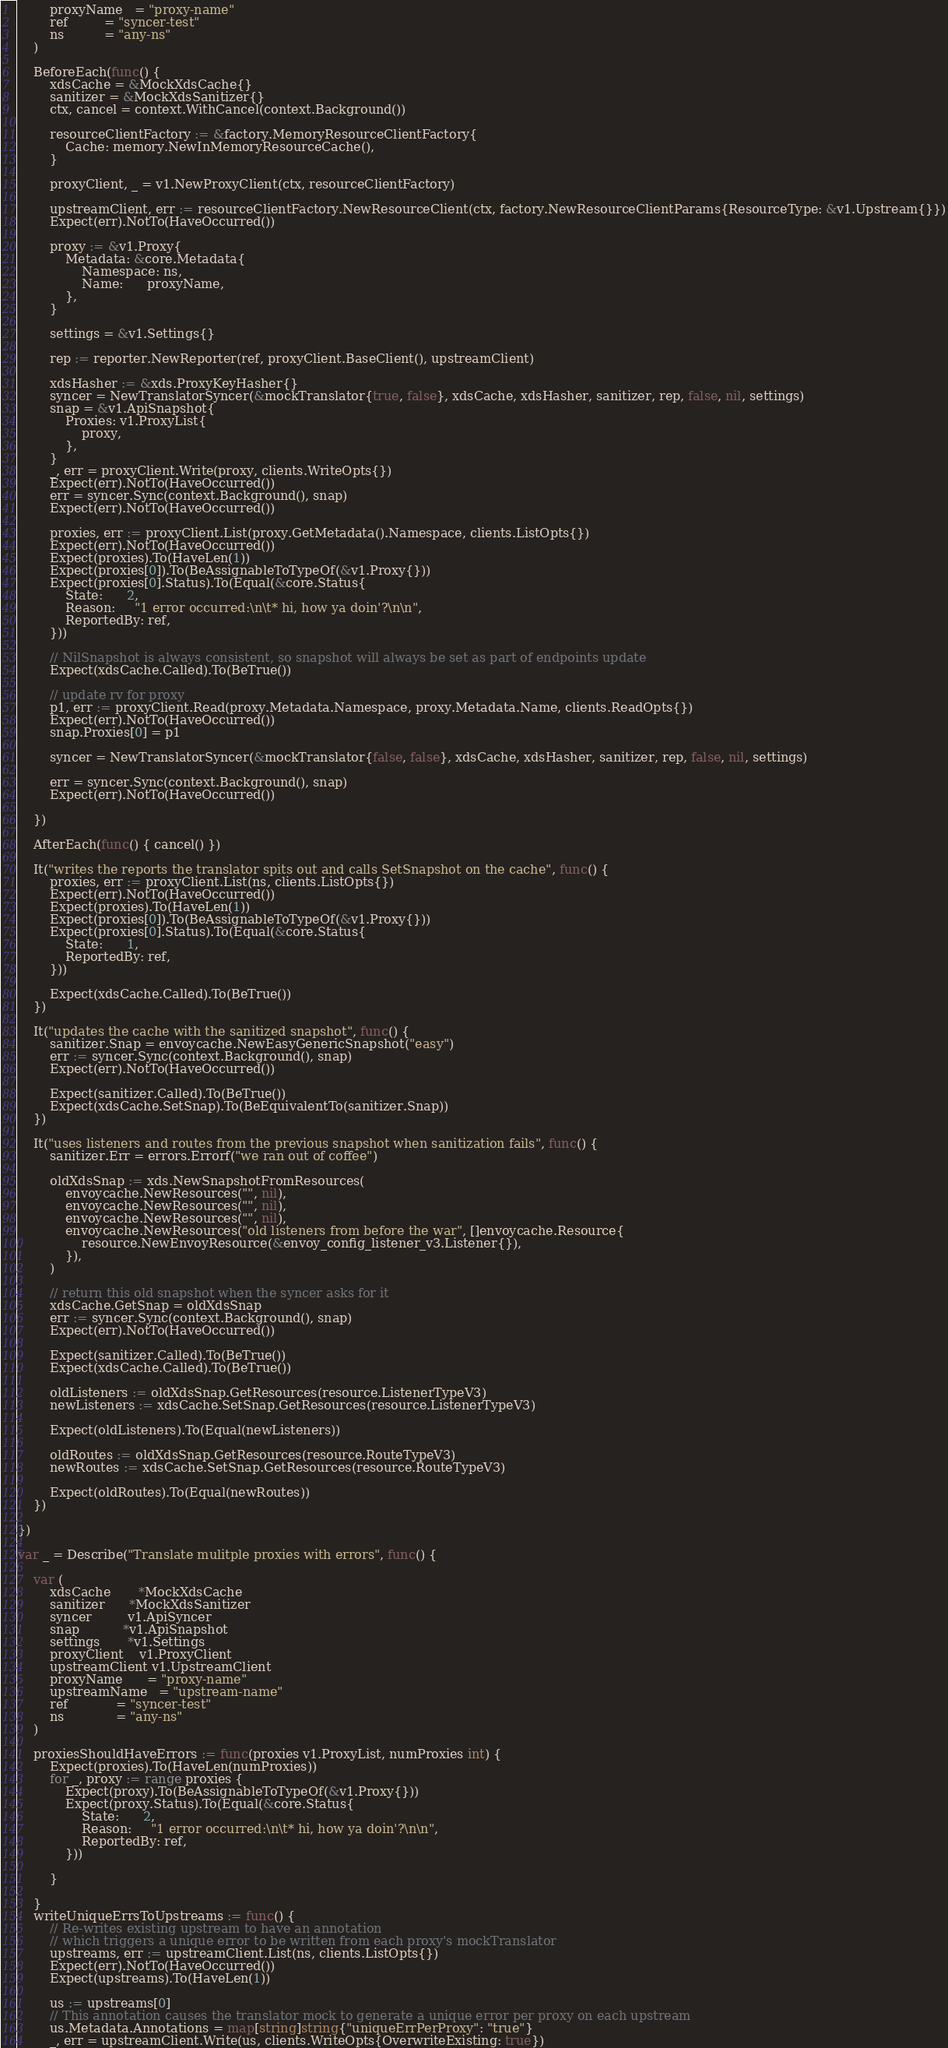<code> <loc_0><loc_0><loc_500><loc_500><_Go_>		proxyName   = "proxy-name"
		ref         = "syncer-test"
		ns          = "any-ns"
	)

	BeforeEach(func() {
		xdsCache = &MockXdsCache{}
		sanitizer = &MockXdsSanitizer{}
		ctx, cancel = context.WithCancel(context.Background())

		resourceClientFactory := &factory.MemoryResourceClientFactory{
			Cache: memory.NewInMemoryResourceCache(),
		}

		proxyClient, _ = v1.NewProxyClient(ctx, resourceClientFactory)

		upstreamClient, err := resourceClientFactory.NewResourceClient(ctx, factory.NewResourceClientParams{ResourceType: &v1.Upstream{}})
		Expect(err).NotTo(HaveOccurred())

		proxy := &v1.Proxy{
			Metadata: &core.Metadata{
				Namespace: ns,
				Name:      proxyName,
			},
		}

		settings = &v1.Settings{}

		rep := reporter.NewReporter(ref, proxyClient.BaseClient(), upstreamClient)

		xdsHasher := &xds.ProxyKeyHasher{}
		syncer = NewTranslatorSyncer(&mockTranslator{true, false}, xdsCache, xdsHasher, sanitizer, rep, false, nil, settings)
		snap = &v1.ApiSnapshot{
			Proxies: v1.ProxyList{
				proxy,
			},
		}
		_, err = proxyClient.Write(proxy, clients.WriteOpts{})
		Expect(err).NotTo(HaveOccurred())
		err = syncer.Sync(context.Background(), snap)
		Expect(err).NotTo(HaveOccurred())

		proxies, err := proxyClient.List(proxy.GetMetadata().Namespace, clients.ListOpts{})
		Expect(err).NotTo(HaveOccurred())
		Expect(proxies).To(HaveLen(1))
		Expect(proxies[0]).To(BeAssignableToTypeOf(&v1.Proxy{}))
		Expect(proxies[0].Status).To(Equal(&core.Status{
			State:      2,
			Reason:     "1 error occurred:\n\t* hi, how ya doin'?\n\n",
			ReportedBy: ref,
		}))

		// NilSnapshot is always consistent, so snapshot will always be set as part of endpoints update
		Expect(xdsCache.Called).To(BeTrue())

		// update rv for proxy
		p1, err := proxyClient.Read(proxy.Metadata.Namespace, proxy.Metadata.Name, clients.ReadOpts{})
		Expect(err).NotTo(HaveOccurred())
		snap.Proxies[0] = p1

		syncer = NewTranslatorSyncer(&mockTranslator{false, false}, xdsCache, xdsHasher, sanitizer, rep, false, nil, settings)

		err = syncer.Sync(context.Background(), snap)
		Expect(err).NotTo(HaveOccurred())

	})

	AfterEach(func() { cancel() })

	It("writes the reports the translator spits out and calls SetSnapshot on the cache", func() {
		proxies, err := proxyClient.List(ns, clients.ListOpts{})
		Expect(err).NotTo(HaveOccurred())
		Expect(proxies).To(HaveLen(1))
		Expect(proxies[0]).To(BeAssignableToTypeOf(&v1.Proxy{}))
		Expect(proxies[0].Status).To(Equal(&core.Status{
			State:      1,
			ReportedBy: ref,
		}))

		Expect(xdsCache.Called).To(BeTrue())
	})

	It("updates the cache with the sanitized snapshot", func() {
		sanitizer.Snap = envoycache.NewEasyGenericSnapshot("easy")
		err := syncer.Sync(context.Background(), snap)
		Expect(err).NotTo(HaveOccurred())

		Expect(sanitizer.Called).To(BeTrue())
		Expect(xdsCache.SetSnap).To(BeEquivalentTo(sanitizer.Snap))
	})

	It("uses listeners and routes from the previous snapshot when sanitization fails", func() {
		sanitizer.Err = errors.Errorf("we ran out of coffee")

		oldXdsSnap := xds.NewSnapshotFromResources(
			envoycache.NewResources("", nil),
			envoycache.NewResources("", nil),
			envoycache.NewResources("", nil),
			envoycache.NewResources("old listeners from before the war", []envoycache.Resource{
				resource.NewEnvoyResource(&envoy_config_listener_v3.Listener{}),
			}),
		)

		// return this old snapshot when the syncer asks for it
		xdsCache.GetSnap = oldXdsSnap
		err := syncer.Sync(context.Background(), snap)
		Expect(err).NotTo(HaveOccurred())

		Expect(sanitizer.Called).To(BeTrue())
		Expect(xdsCache.Called).To(BeTrue())

		oldListeners := oldXdsSnap.GetResources(resource.ListenerTypeV3)
		newListeners := xdsCache.SetSnap.GetResources(resource.ListenerTypeV3)

		Expect(oldListeners).To(Equal(newListeners))

		oldRoutes := oldXdsSnap.GetResources(resource.RouteTypeV3)
		newRoutes := xdsCache.SetSnap.GetResources(resource.RouteTypeV3)

		Expect(oldRoutes).To(Equal(newRoutes))
	})

})

var _ = Describe("Translate mulitple proxies with errors", func() {

	var (
		xdsCache       *MockXdsCache
		sanitizer      *MockXdsSanitizer
		syncer         v1.ApiSyncer
		snap           *v1.ApiSnapshot
		settings       *v1.Settings
		proxyClient    v1.ProxyClient
		upstreamClient v1.UpstreamClient
		proxyName      = "proxy-name"
		upstreamName   = "upstream-name"
		ref            = "syncer-test"
		ns             = "any-ns"
	)

	proxiesShouldHaveErrors := func(proxies v1.ProxyList, numProxies int) {
		Expect(proxies).To(HaveLen(numProxies))
		for _, proxy := range proxies {
			Expect(proxy).To(BeAssignableToTypeOf(&v1.Proxy{}))
			Expect(proxy.Status).To(Equal(&core.Status{
				State:      2,
				Reason:     "1 error occurred:\n\t* hi, how ya doin'?\n\n",
				ReportedBy: ref,
			}))

		}

	}
	writeUniqueErrsToUpstreams := func() {
		// Re-writes existing upstream to have an annotation
		// which triggers a unique error to be written from each proxy's mockTranslator
		upstreams, err := upstreamClient.List(ns, clients.ListOpts{})
		Expect(err).NotTo(HaveOccurred())
		Expect(upstreams).To(HaveLen(1))

		us := upstreams[0]
		// This annotation causes the translator mock to generate a unique error per proxy on each upstream
		us.Metadata.Annotations = map[string]string{"uniqueErrPerProxy": "true"}
		_, err = upstreamClient.Write(us, clients.WriteOpts{OverwriteExisting: true})</code> 